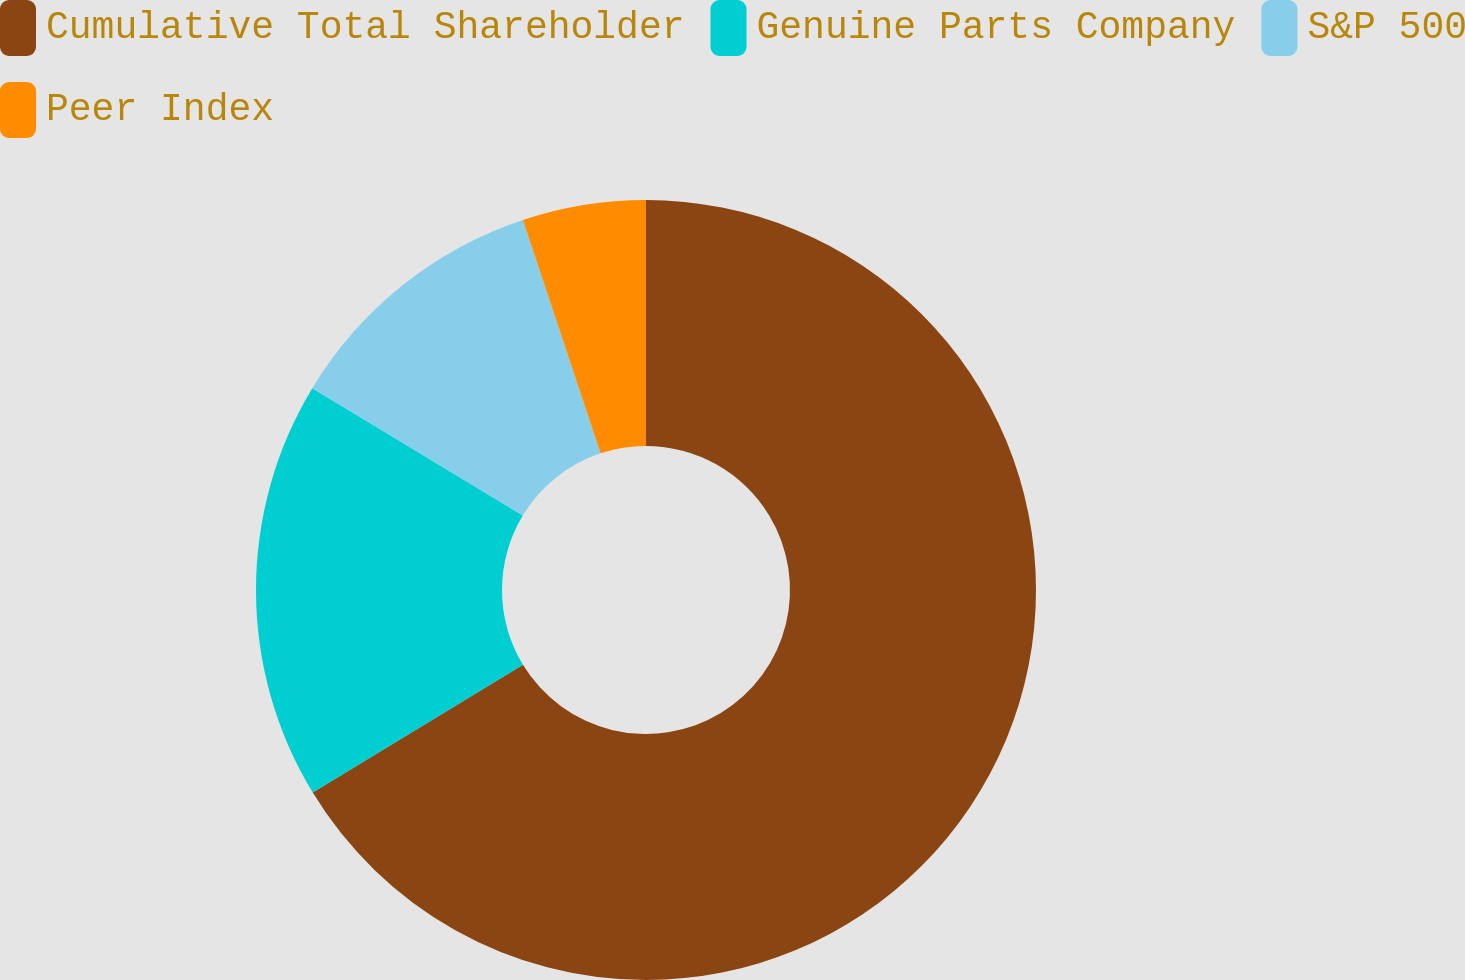Convert chart. <chart><loc_0><loc_0><loc_500><loc_500><pie_chart><fcel>Cumulative Total Shareholder<fcel>Genuine Parts Company<fcel>S&P 500<fcel>Peer Index<nl><fcel>66.3%<fcel>17.35%<fcel>11.23%<fcel>5.11%<nl></chart> 